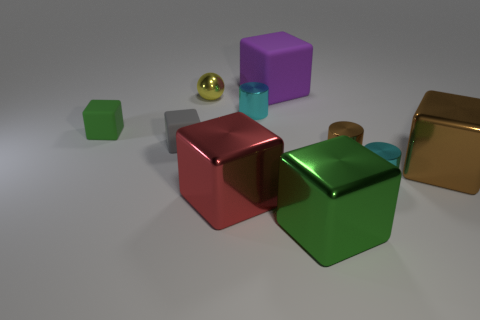What number of balls are the same color as the big matte cube?
Provide a succinct answer. 0. How many gray spheres are there?
Offer a terse response. 0. What number of tiny green blocks have the same material as the red block?
Make the answer very short. 0. What size is the red thing that is the same shape as the big brown shiny object?
Your answer should be compact. Large. What is the tiny green cube made of?
Your response must be concise. Rubber. There is a big green cube that is in front of the cyan metallic cylinder behind the large metallic block that is behind the big red metallic cube; what is it made of?
Keep it short and to the point. Metal. Are there any other things that have the same shape as the red shiny object?
Your response must be concise. Yes. There is another large matte object that is the same shape as the green matte thing; what is its color?
Provide a short and direct response. Purple. Is the color of the rubber block that is behind the yellow metallic thing the same as the tiny matte object that is to the right of the tiny green matte block?
Provide a succinct answer. No. Is the number of green metal things that are behind the yellow sphere greater than the number of small green matte cubes?
Offer a very short reply. No. 